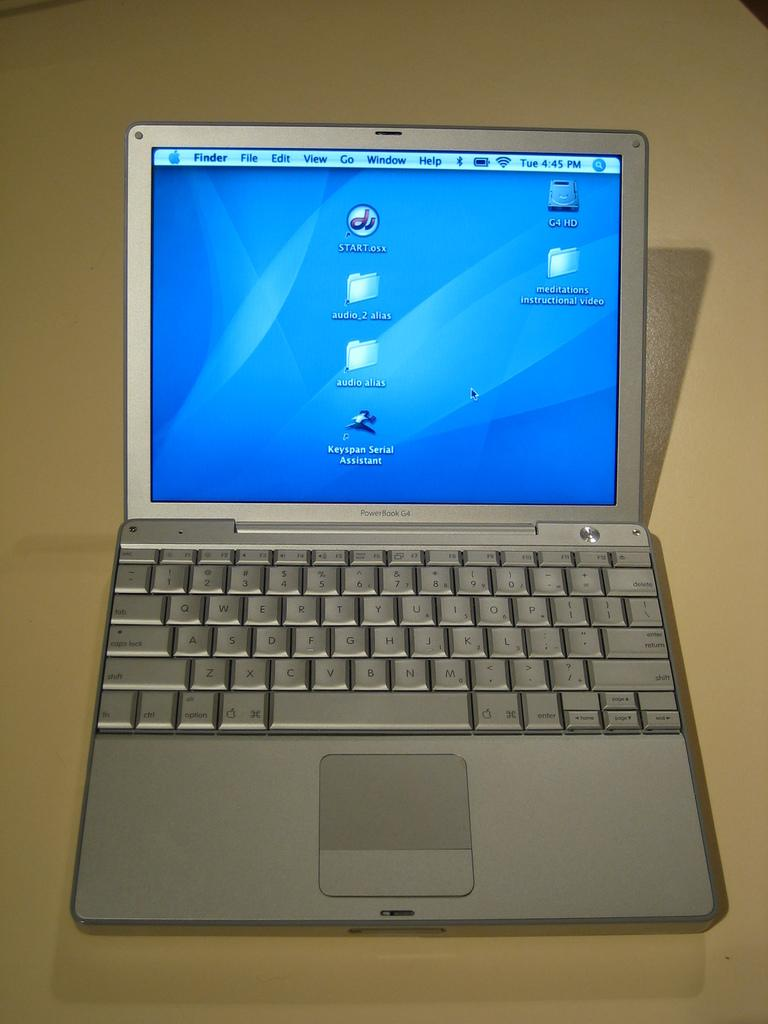<image>
Offer a succinct explanation of the picture presented. A silver laptop called Power Book G4 is open to the desktop. 